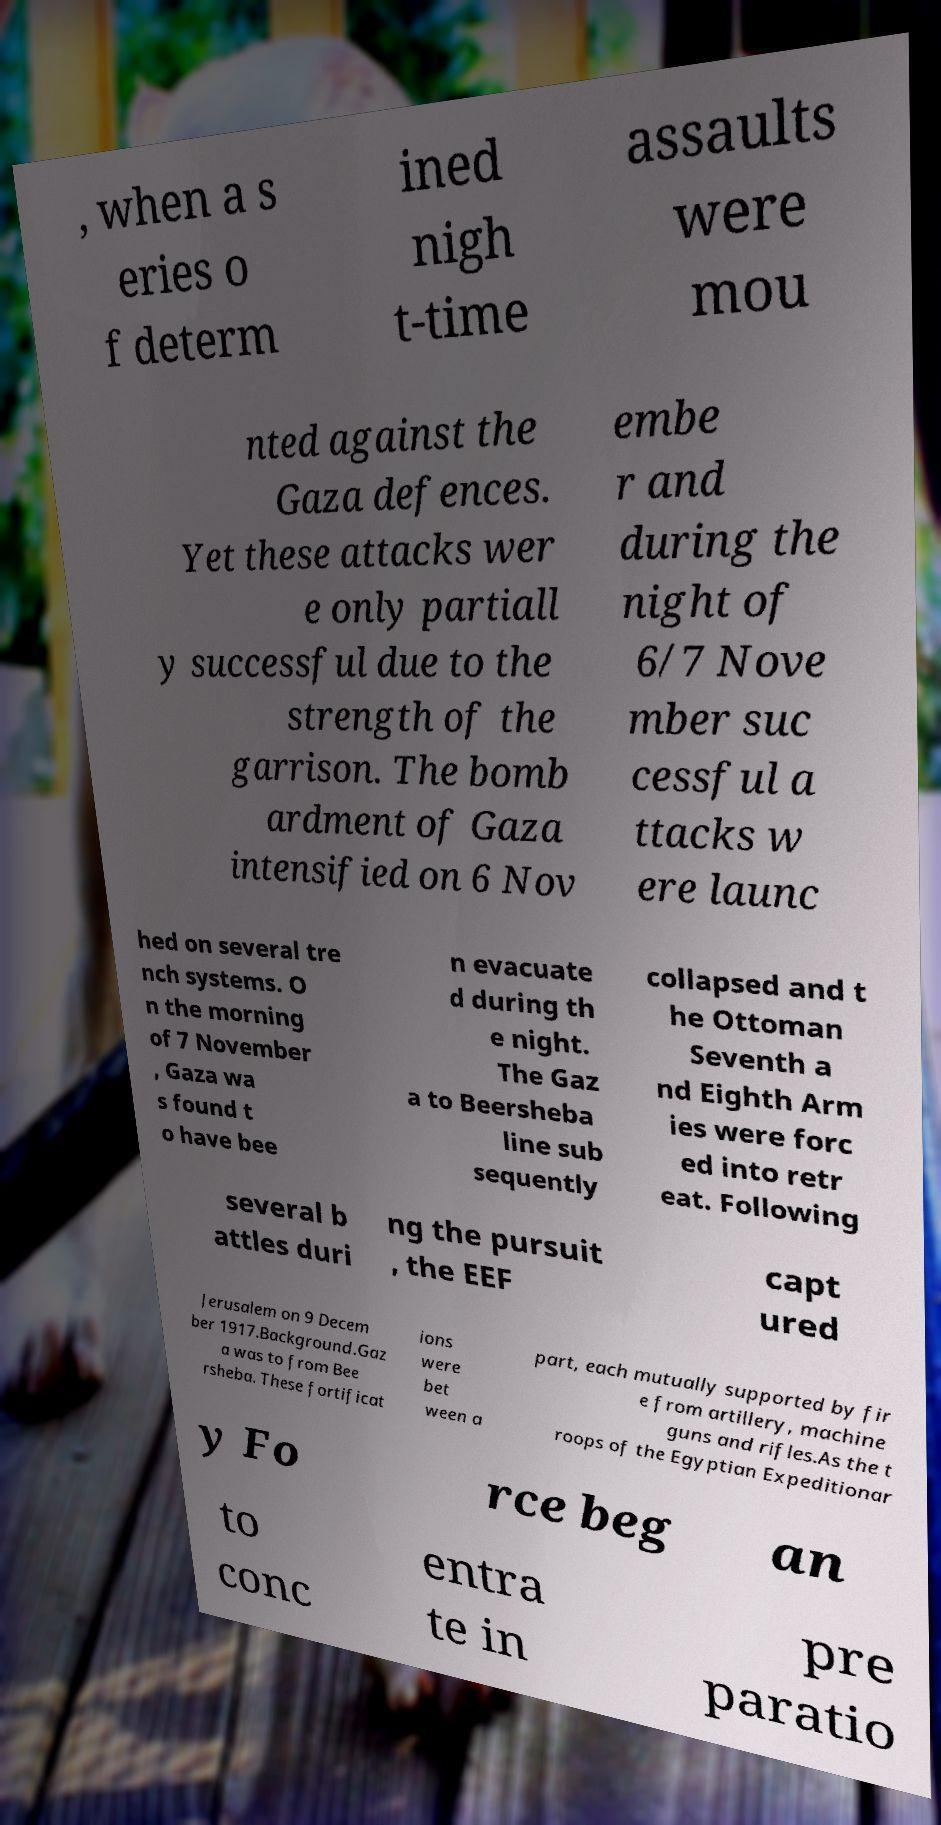Can you read and provide the text displayed in the image?This photo seems to have some interesting text. Can you extract and type it out for me? , when a s eries o f determ ined nigh t-time assaults were mou nted against the Gaza defences. Yet these attacks wer e only partiall y successful due to the strength of the garrison. The bomb ardment of Gaza intensified on 6 Nov embe r and during the night of 6/7 Nove mber suc cessful a ttacks w ere launc hed on several tre nch systems. O n the morning of 7 November , Gaza wa s found t o have bee n evacuate d during th e night. The Gaz a to Beersheba line sub sequently collapsed and t he Ottoman Seventh a nd Eighth Arm ies were forc ed into retr eat. Following several b attles duri ng the pursuit , the EEF capt ured Jerusalem on 9 Decem ber 1917.Background.Gaz a was to from Bee rsheba. These fortificat ions were bet ween a part, each mutually supported by fir e from artillery, machine guns and rifles.As the t roops of the Egyptian Expeditionar y Fo rce beg an to conc entra te in pre paratio 